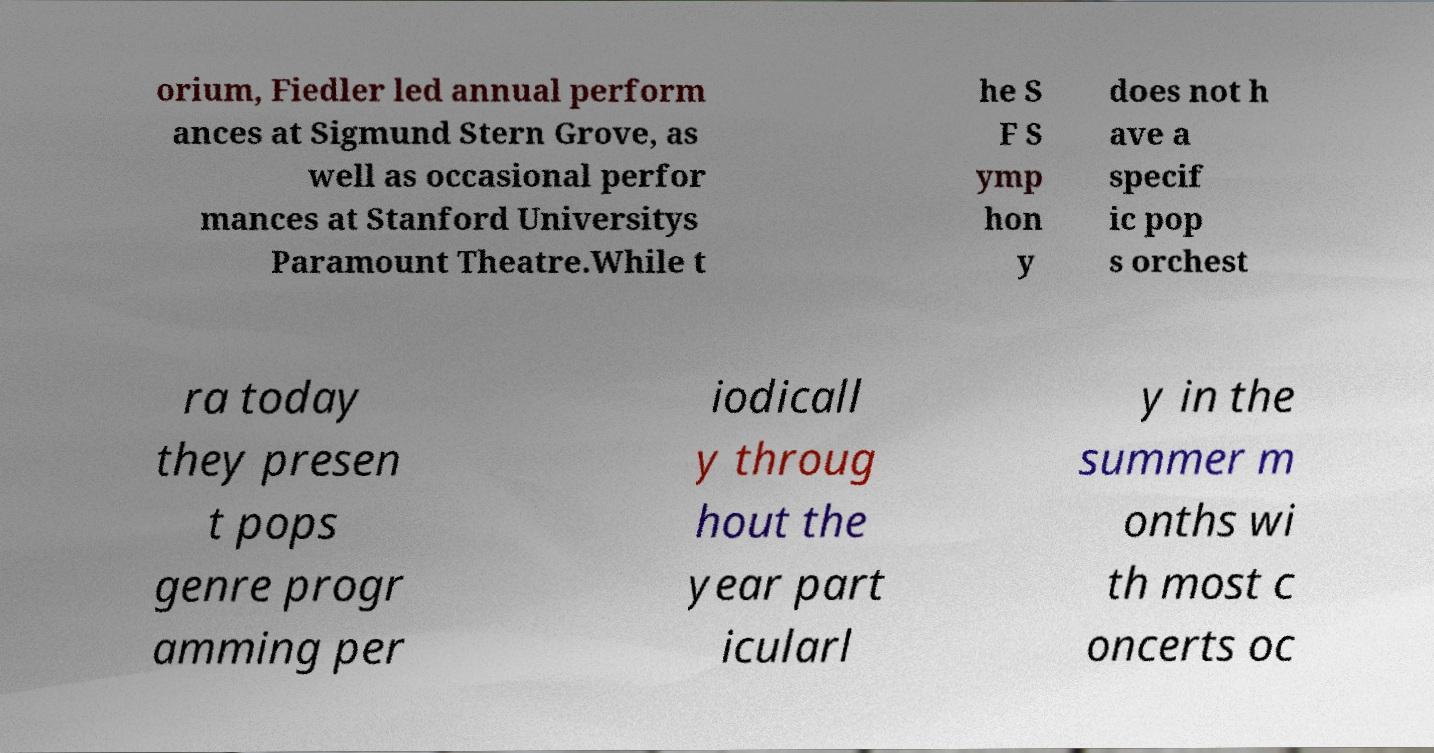I need the written content from this picture converted into text. Can you do that? orium, Fiedler led annual perform ances at Sigmund Stern Grove, as well as occasional perfor mances at Stanford Universitys Paramount Theatre.While t he S F S ymp hon y does not h ave a specif ic pop s orchest ra today they presen t pops genre progr amming per iodicall y throug hout the year part icularl y in the summer m onths wi th most c oncerts oc 